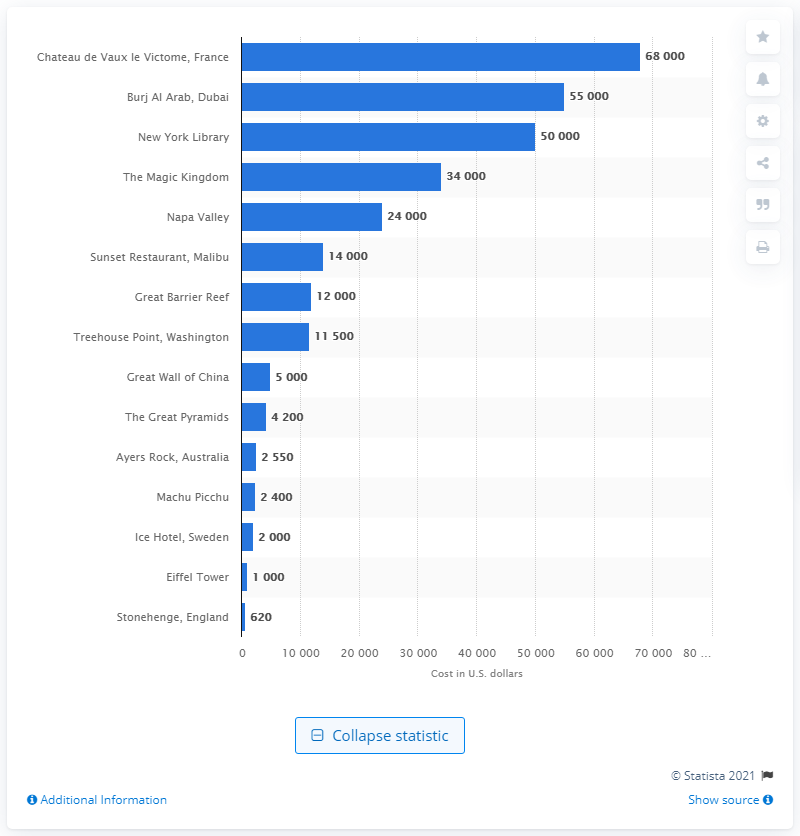Point out several critical features in this image. The cost of hosting a wedding in the New York Public Library in September 2014 was approximately $50,000. 